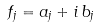Convert formula to latex. <formula><loc_0><loc_0><loc_500><loc_500>f _ { j } = a _ { j } + i \, b _ { j }</formula> 